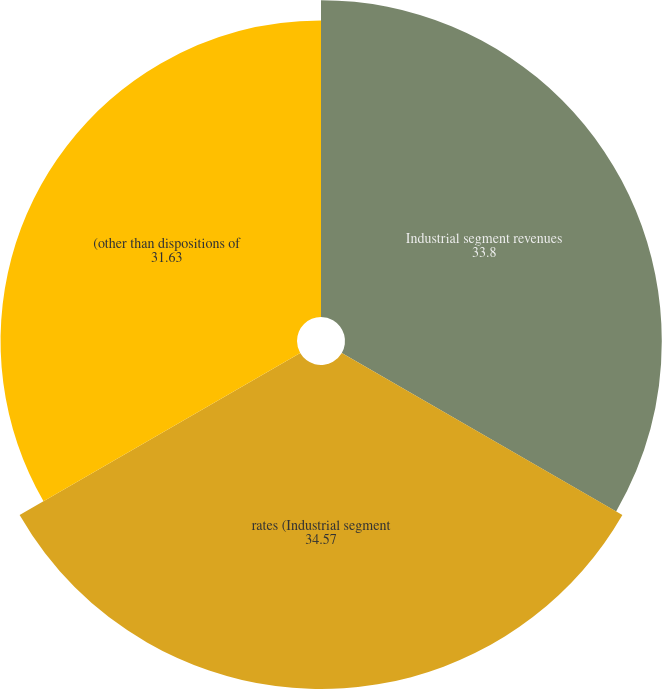Convert chart. <chart><loc_0><loc_0><loc_500><loc_500><pie_chart><fcel>Industrial segment revenues<fcel>rates (Industrial segment<fcel>(other than dispositions of<nl><fcel>33.8%<fcel>34.57%<fcel>31.63%<nl></chart> 